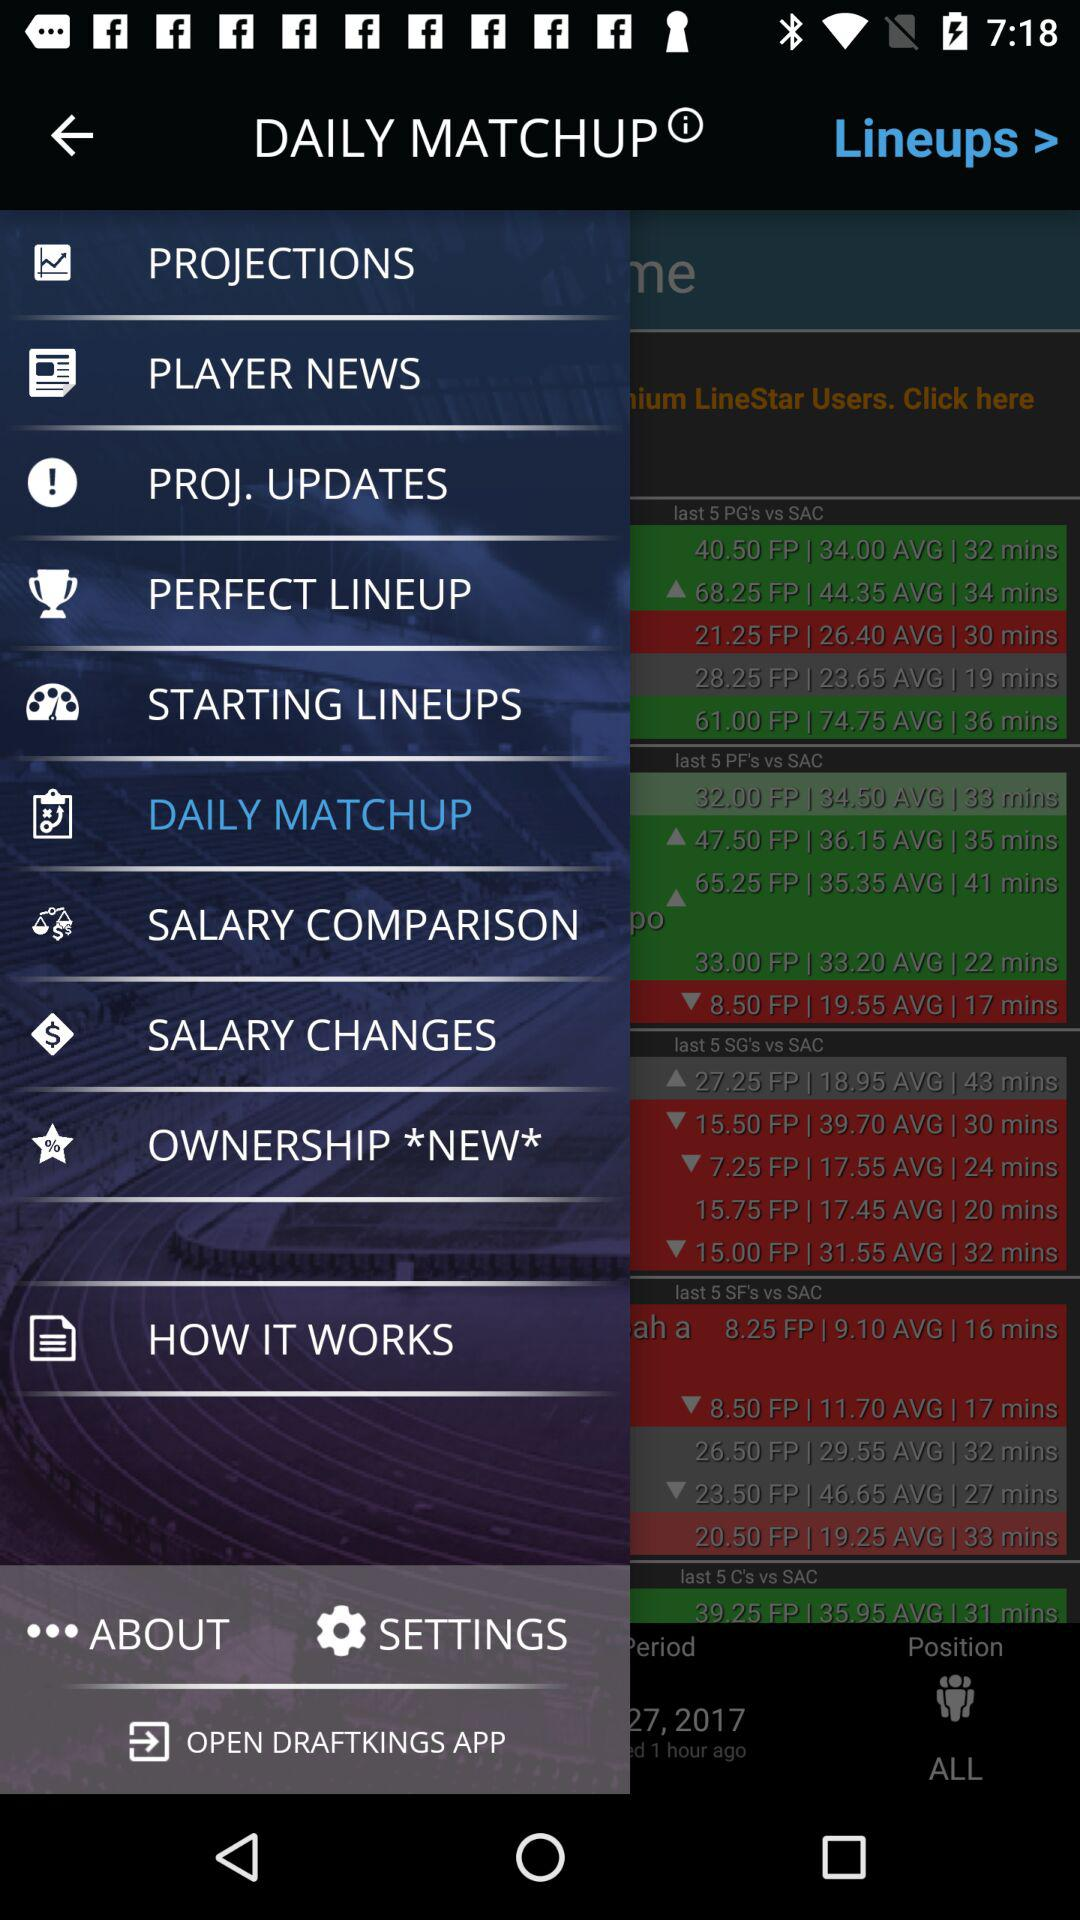Which item is selected in the menu? The selected item in the menu is "DAILY MATCHUP". 